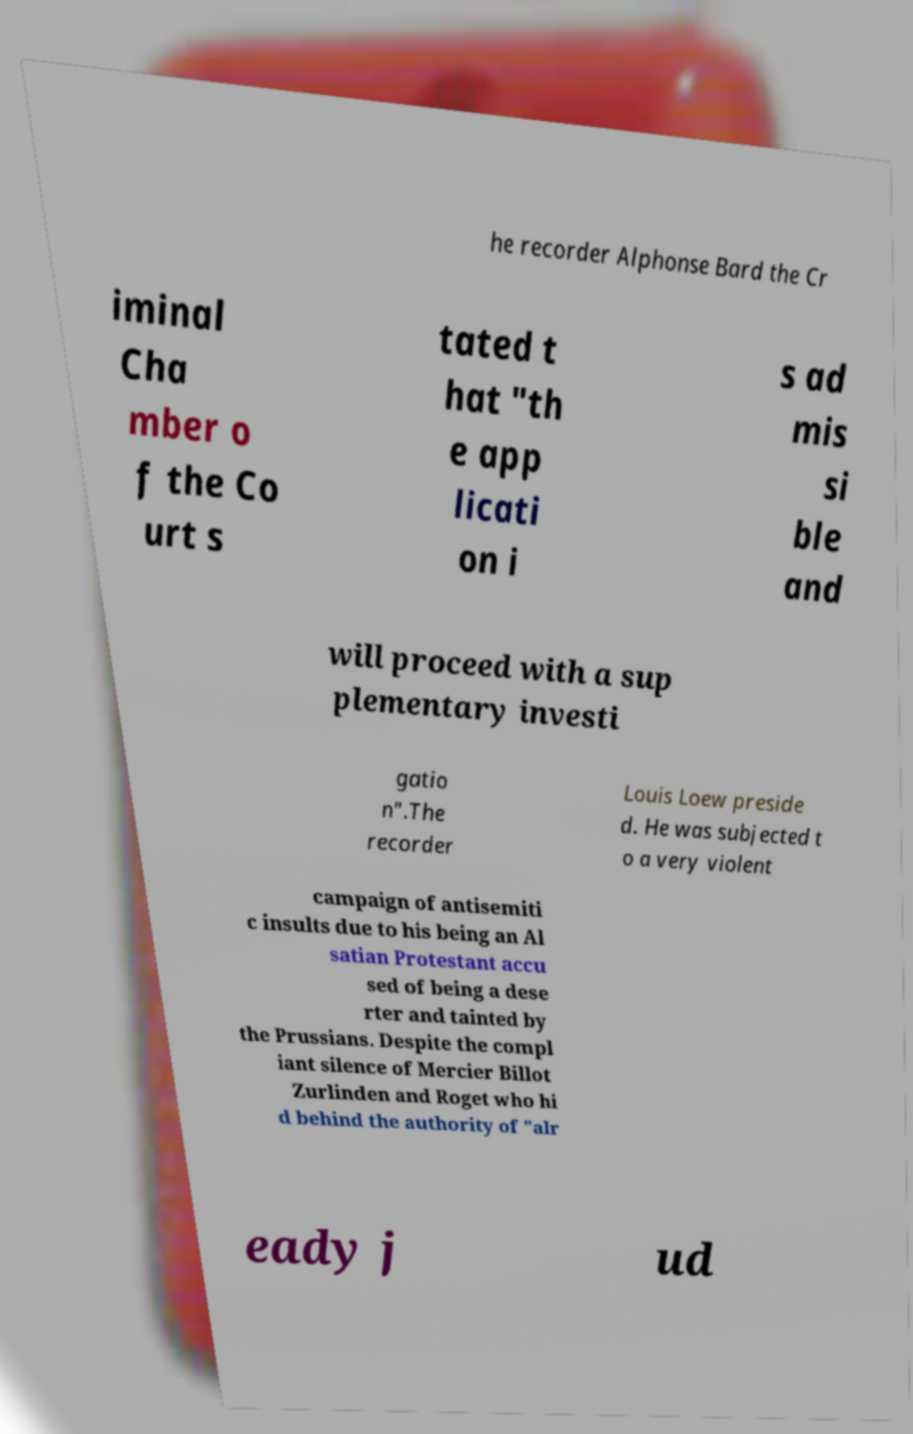Can you accurately transcribe the text from the provided image for me? he recorder Alphonse Bard the Cr iminal Cha mber o f the Co urt s tated t hat "th e app licati on i s ad mis si ble and will proceed with a sup plementary investi gatio n".The recorder Louis Loew preside d. He was subjected t o a very violent campaign of antisemiti c insults due to his being an Al satian Protestant accu sed of being a dese rter and tainted by the Prussians. Despite the compl iant silence of Mercier Billot Zurlinden and Roget who hi d behind the authority of "alr eady j ud 